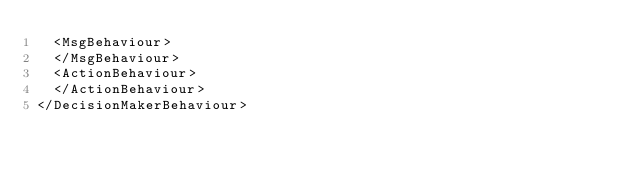Convert code to text. <code><loc_0><loc_0><loc_500><loc_500><_XML_>  <MsgBehaviour>
  </MsgBehaviour>
  <ActionBehaviour>
  </ActionBehaviour>
</DecisionMakerBehaviour>
</code> 